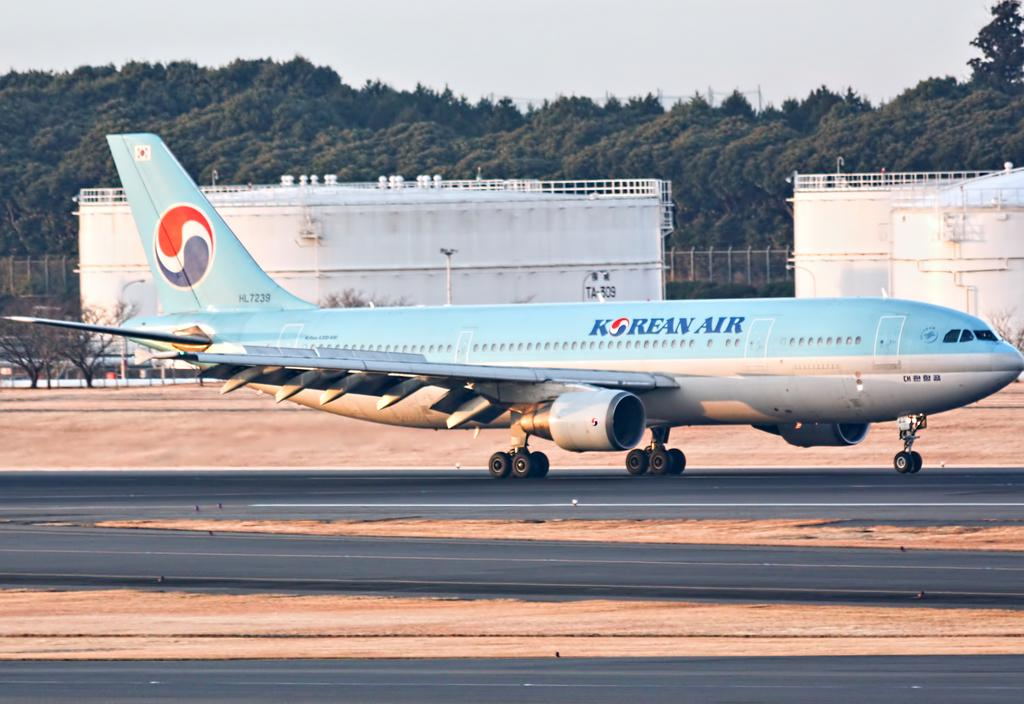What is the main subject of the image? The main subject of the image is an airplane on the runway. What can be seen in the background of the image? In the background of the image, there are buildings, a fence, a group of trees, and the sky. How would you describe the sky in the image? The sky appears cloudy in the image. What type of substance is being used by the doctor in the image? There is no doctor or substance present in the image; it features an airplane on the runway with a background of buildings, a fence, trees, and a cloudy sky. 